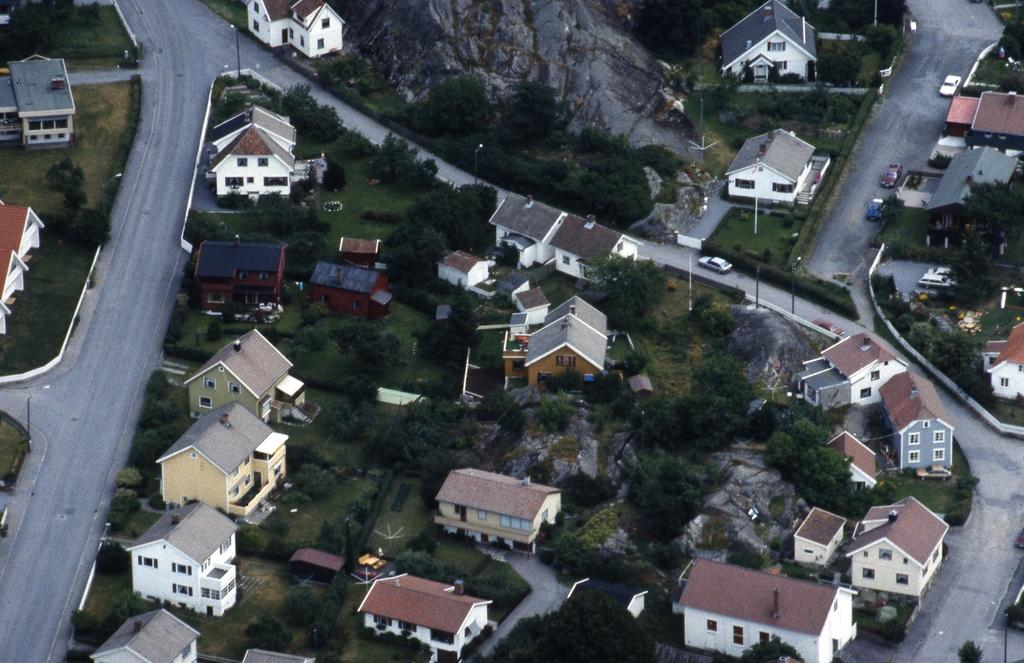What type of structures can be seen in the image? There are many houses and buildings in the image. What natural elements are present in the image? There are trees, plants, grass, and a mountain in the image. How are the houses and buildings connected in the image? There are roads on the left side of the image that connect the houses and buildings. What additional features can be seen beside the roads? There are street lights beside the roads. What type of invention can be seen in the image? There is no specific invention visible in the image; it primarily features houses, buildings, roads, and natural elements. 